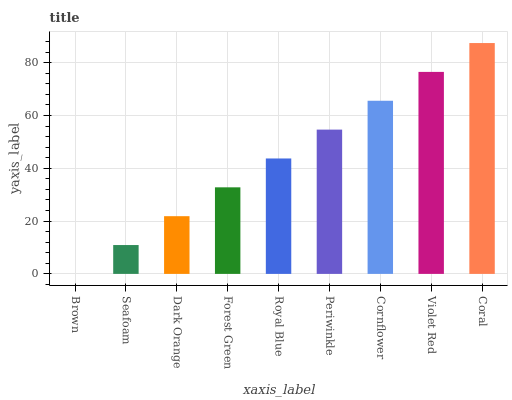Is Brown the minimum?
Answer yes or no. Yes. Is Coral the maximum?
Answer yes or no. Yes. Is Seafoam the minimum?
Answer yes or no. No. Is Seafoam the maximum?
Answer yes or no. No. Is Seafoam greater than Brown?
Answer yes or no. Yes. Is Brown less than Seafoam?
Answer yes or no. Yes. Is Brown greater than Seafoam?
Answer yes or no. No. Is Seafoam less than Brown?
Answer yes or no. No. Is Royal Blue the high median?
Answer yes or no. Yes. Is Royal Blue the low median?
Answer yes or no. Yes. Is Violet Red the high median?
Answer yes or no. No. Is Brown the low median?
Answer yes or no. No. 